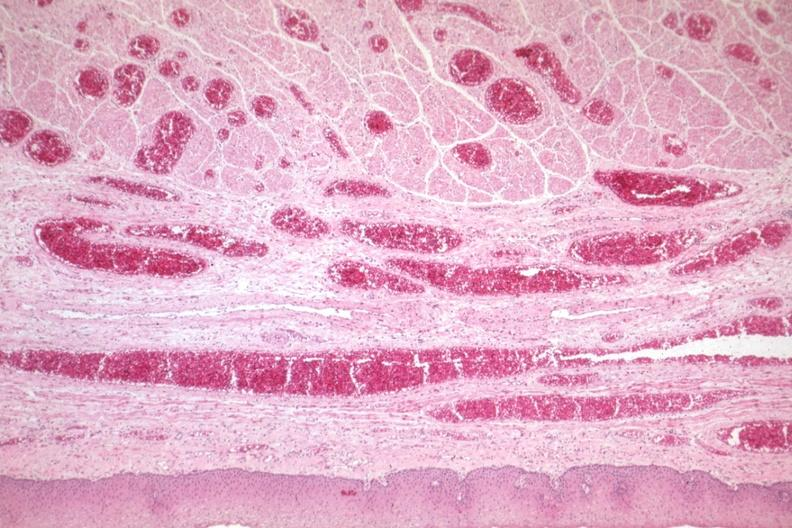does leiomyoma show good example of veins filled with blood?
Answer the question using a single word or phrase. No 